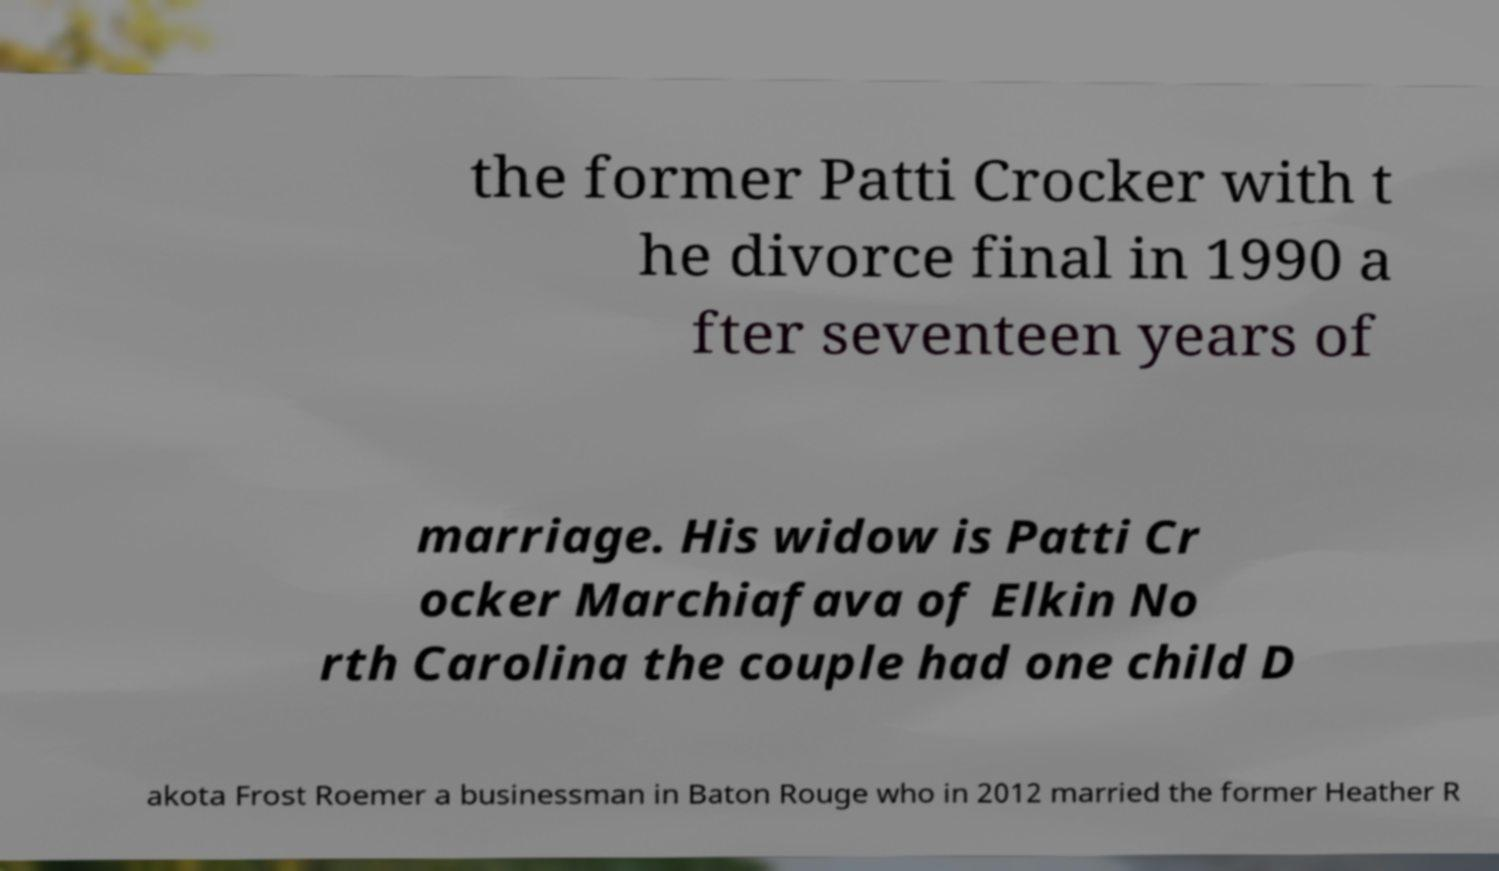Please read and relay the text visible in this image. What does it say? the former Patti Crocker with t he divorce final in 1990 a fter seventeen years of marriage. His widow is Patti Cr ocker Marchiafava of Elkin No rth Carolina the couple had one child D akota Frost Roemer a businessman in Baton Rouge who in 2012 married the former Heather R 